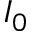<formula> <loc_0><loc_0><loc_500><loc_500>I _ { 0 }</formula> 